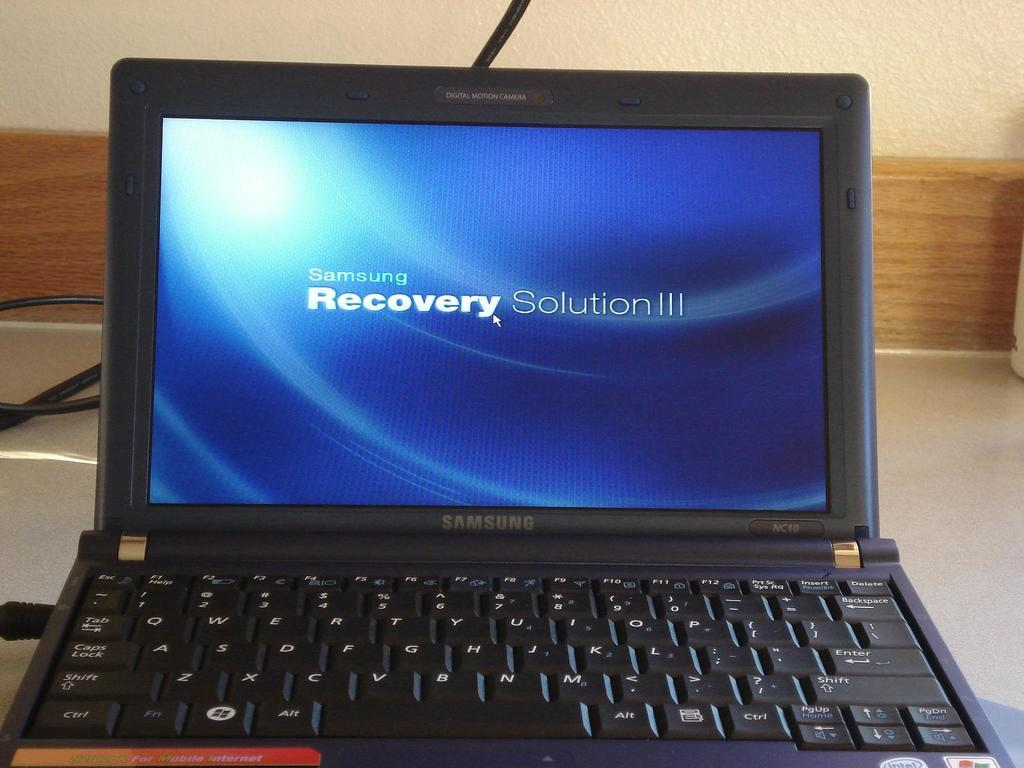<image>
Provide a brief description of the given image. A laptop made by Samsung says Samsung Recovery Solution III. 